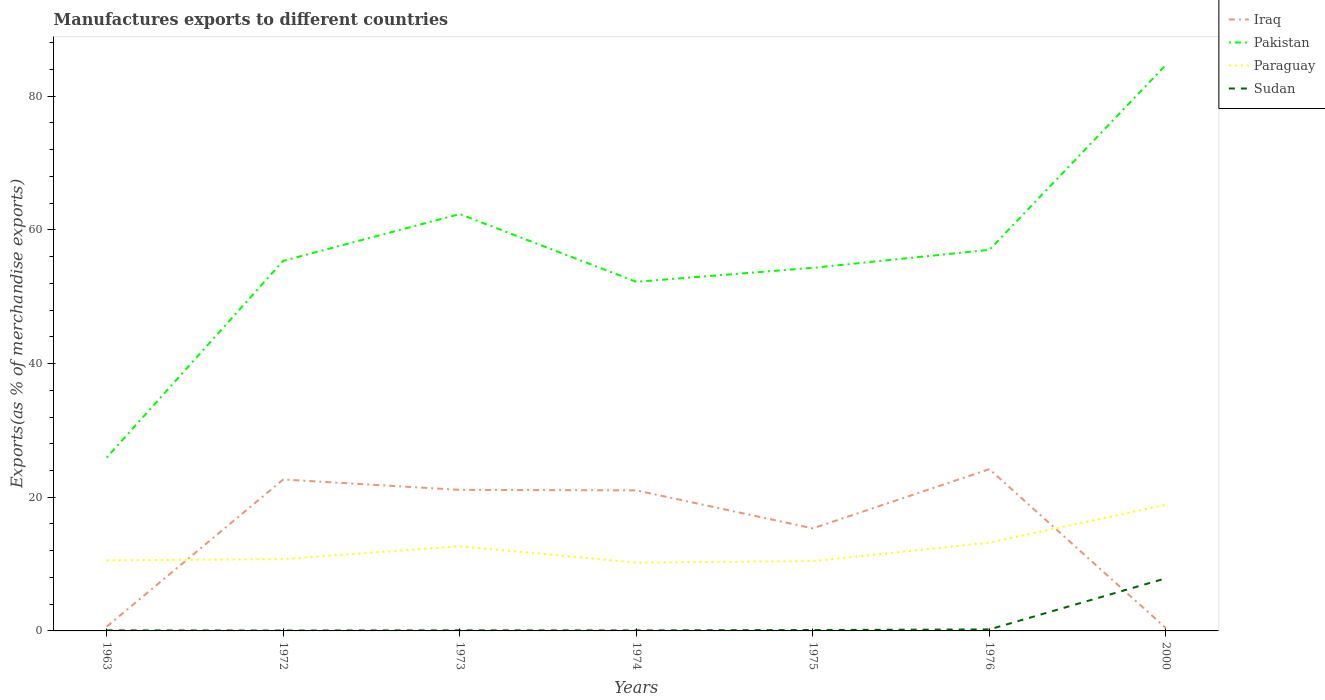How many different coloured lines are there?
Your answer should be very brief. 4. Does the line corresponding to Sudan intersect with the line corresponding to Iraq?
Offer a very short reply. Yes. Across all years, what is the maximum percentage of exports to different countries in Pakistan?
Ensure brevity in your answer.  25.94. In which year was the percentage of exports to different countries in Paraguay maximum?
Your response must be concise. 1974. What is the total percentage of exports to different countries in Paraguay in the graph?
Offer a very short reply. -2.46. What is the difference between the highest and the second highest percentage of exports to different countries in Sudan?
Ensure brevity in your answer.  7.82. What is the difference between the highest and the lowest percentage of exports to different countries in Iraq?
Make the answer very short. 5. Is the percentage of exports to different countries in Sudan strictly greater than the percentage of exports to different countries in Paraguay over the years?
Your answer should be compact. Yes. How many lines are there?
Your answer should be compact. 4. How many years are there in the graph?
Keep it short and to the point. 7. Does the graph contain any zero values?
Ensure brevity in your answer.  No. Where does the legend appear in the graph?
Make the answer very short. Top right. What is the title of the graph?
Keep it short and to the point. Manufactures exports to different countries. What is the label or title of the X-axis?
Give a very brief answer. Years. What is the label or title of the Y-axis?
Provide a succinct answer. Exports(as % of merchandise exports). What is the Exports(as % of merchandise exports) of Iraq in 1963?
Make the answer very short. 0.64. What is the Exports(as % of merchandise exports) of Pakistan in 1963?
Ensure brevity in your answer.  25.94. What is the Exports(as % of merchandise exports) in Paraguay in 1963?
Offer a terse response. 10.55. What is the Exports(as % of merchandise exports) in Sudan in 1963?
Provide a short and direct response. 0.09. What is the Exports(as % of merchandise exports) in Iraq in 1972?
Ensure brevity in your answer.  22.66. What is the Exports(as % of merchandise exports) in Pakistan in 1972?
Give a very brief answer. 55.37. What is the Exports(as % of merchandise exports) in Paraguay in 1972?
Make the answer very short. 10.75. What is the Exports(as % of merchandise exports) of Sudan in 1972?
Give a very brief answer. 0.06. What is the Exports(as % of merchandise exports) of Iraq in 1973?
Offer a terse response. 21.11. What is the Exports(as % of merchandise exports) in Pakistan in 1973?
Your answer should be compact. 62.37. What is the Exports(as % of merchandise exports) in Paraguay in 1973?
Offer a very short reply. 12.66. What is the Exports(as % of merchandise exports) in Sudan in 1973?
Make the answer very short. 0.09. What is the Exports(as % of merchandise exports) in Iraq in 1974?
Give a very brief answer. 21.03. What is the Exports(as % of merchandise exports) of Pakistan in 1974?
Offer a very short reply. 52.24. What is the Exports(as % of merchandise exports) of Paraguay in 1974?
Your answer should be very brief. 10.22. What is the Exports(as % of merchandise exports) of Sudan in 1974?
Keep it short and to the point. 0.08. What is the Exports(as % of merchandise exports) in Iraq in 1975?
Make the answer very short. 15.34. What is the Exports(as % of merchandise exports) of Pakistan in 1975?
Offer a very short reply. 54.33. What is the Exports(as % of merchandise exports) in Paraguay in 1975?
Provide a short and direct response. 10.45. What is the Exports(as % of merchandise exports) in Sudan in 1975?
Provide a short and direct response. 0.13. What is the Exports(as % of merchandise exports) of Iraq in 1976?
Keep it short and to the point. 24.21. What is the Exports(as % of merchandise exports) in Pakistan in 1976?
Your response must be concise. 57.02. What is the Exports(as % of merchandise exports) in Paraguay in 1976?
Your response must be concise. 13.21. What is the Exports(as % of merchandise exports) of Sudan in 1976?
Ensure brevity in your answer.  0.23. What is the Exports(as % of merchandise exports) in Iraq in 2000?
Offer a terse response. 0.42. What is the Exports(as % of merchandise exports) in Pakistan in 2000?
Offer a terse response. 84.7. What is the Exports(as % of merchandise exports) in Paraguay in 2000?
Give a very brief answer. 18.88. What is the Exports(as % of merchandise exports) in Sudan in 2000?
Make the answer very short. 7.87. Across all years, what is the maximum Exports(as % of merchandise exports) in Iraq?
Provide a short and direct response. 24.21. Across all years, what is the maximum Exports(as % of merchandise exports) in Pakistan?
Offer a very short reply. 84.7. Across all years, what is the maximum Exports(as % of merchandise exports) of Paraguay?
Your answer should be very brief. 18.88. Across all years, what is the maximum Exports(as % of merchandise exports) in Sudan?
Give a very brief answer. 7.87. Across all years, what is the minimum Exports(as % of merchandise exports) in Iraq?
Your response must be concise. 0.42. Across all years, what is the minimum Exports(as % of merchandise exports) in Pakistan?
Your response must be concise. 25.94. Across all years, what is the minimum Exports(as % of merchandise exports) in Paraguay?
Make the answer very short. 10.22. Across all years, what is the minimum Exports(as % of merchandise exports) in Sudan?
Provide a short and direct response. 0.06. What is the total Exports(as % of merchandise exports) in Iraq in the graph?
Make the answer very short. 105.4. What is the total Exports(as % of merchandise exports) in Pakistan in the graph?
Give a very brief answer. 391.96. What is the total Exports(as % of merchandise exports) of Paraguay in the graph?
Ensure brevity in your answer.  86.72. What is the total Exports(as % of merchandise exports) in Sudan in the graph?
Ensure brevity in your answer.  8.55. What is the difference between the Exports(as % of merchandise exports) of Iraq in 1963 and that in 1972?
Keep it short and to the point. -22.01. What is the difference between the Exports(as % of merchandise exports) in Pakistan in 1963 and that in 1972?
Offer a terse response. -29.44. What is the difference between the Exports(as % of merchandise exports) in Paraguay in 1963 and that in 1972?
Keep it short and to the point. -0.2. What is the difference between the Exports(as % of merchandise exports) of Sudan in 1963 and that in 1972?
Make the answer very short. 0.03. What is the difference between the Exports(as % of merchandise exports) in Iraq in 1963 and that in 1973?
Your answer should be compact. -20.46. What is the difference between the Exports(as % of merchandise exports) of Pakistan in 1963 and that in 1973?
Give a very brief answer. -36.44. What is the difference between the Exports(as % of merchandise exports) in Paraguay in 1963 and that in 1973?
Provide a succinct answer. -2.11. What is the difference between the Exports(as % of merchandise exports) of Sudan in 1963 and that in 1973?
Provide a short and direct response. -0. What is the difference between the Exports(as % of merchandise exports) of Iraq in 1963 and that in 1974?
Offer a terse response. -20.39. What is the difference between the Exports(as % of merchandise exports) in Pakistan in 1963 and that in 1974?
Provide a succinct answer. -26.3. What is the difference between the Exports(as % of merchandise exports) in Paraguay in 1963 and that in 1974?
Make the answer very short. 0.33. What is the difference between the Exports(as % of merchandise exports) of Sudan in 1963 and that in 1974?
Keep it short and to the point. 0.01. What is the difference between the Exports(as % of merchandise exports) of Iraq in 1963 and that in 1975?
Give a very brief answer. -14.7. What is the difference between the Exports(as % of merchandise exports) in Pakistan in 1963 and that in 1975?
Your answer should be compact. -28.39. What is the difference between the Exports(as % of merchandise exports) in Paraguay in 1963 and that in 1975?
Your response must be concise. 0.11. What is the difference between the Exports(as % of merchandise exports) of Sudan in 1963 and that in 1975?
Provide a succinct answer. -0.05. What is the difference between the Exports(as % of merchandise exports) of Iraq in 1963 and that in 1976?
Offer a terse response. -23.57. What is the difference between the Exports(as % of merchandise exports) of Pakistan in 1963 and that in 1976?
Your answer should be compact. -31.08. What is the difference between the Exports(as % of merchandise exports) in Paraguay in 1963 and that in 1976?
Offer a terse response. -2.65. What is the difference between the Exports(as % of merchandise exports) of Sudan in 1963 and that in 1976?
Offer a very short reply. -0.14. What is the difference between the Exports(as % of merchandise exports) of Iraq in 1963 and that in 2000?
Offer a very short reply. 0.23. What is the difference between the Exports(as % of merchandise exports) of Pakistan in 1963 and that in 2000?
Keep it short and to the point. -58.76. What is the difference between the Exports(as % of merchandise exports) in Paraguay in 1963 and that in 2000?
Give a very brief answer. -8.32. What is the difference between the Exports(as % of merchandise exports) of Sudan in 1963 and that in 2000?
Give a very brief answer. -7.79. What is the difference between the Exports(as % of merchandise exports) of Iraq in 1972 and that in 1973?
Your answer should be very brief. 1.55. What is the difference between the Exports(as % of merchandise exports) in Pakistan in 1972 and that in 1973?
Your answer should be very brief. -7. What is the difference between the Exports(as % of merchandise exports) of Paraguay in 1972 and that in 1973?
Your response must be concise. -1.91. What is the difference between the Exports(as % of merchandise exports) of Sudan in 1972 and that in 1973?
Ensure brevity in your answer.  -0.03. What is the difference between the Exports(as % of merchandise exports) of Iraq in 1972 and that in 1974?
Offer a very short reply. 1.62. What is the difference between the Exports(as % of merchandise exports) in Pakistan in 1972 and that in 1974?
Ensure brevity in your answer.  3.14. What is the difference between the Exports(as % of merchandise exports) in Paraguay in 1972 and that in 1974?
Your response must be concise. 0.53. What is the difference between the Exports(as % of merchandise exports) of Sudan in 1972 and that in 1974?
Provide a short and direct response. -0.02. What is the difference between the Exports(as % of merchandise exports) of Iraq in 1972 and that in 1975?
Offer a very short reply. 7.31. What is the difference between the Exports(as % of merchandise exports) of Pakistan in 1972 and that in 1975?
Offer a very short reply. 1.05. What is the difference between the Exports(as % of merchandise exports) of Paraguay in 1972 and that in 1975?
Provide a short and direct response. 0.31. What is the difference between the Exports(as % of merchandise exports) of Sudan in 1972 and that in 1975?
Make the answer very short. -0.08. What is the difference between the Exports(as % of merchandise exports) in Iraq in 1972 and that in 1976?
Your answer should be compact. -1.55. What is the difference between the Exports(as % of merchandise exports) of Pakistan in 1972 and that in 1976?
Your answer should be compact. -1.64. What is the difference between the Exports(as % of merchandise exports) of Paraguay in 1972 and that in 1976?
Your response must be concise. -2.46. What is the difference between the Exports(as % of merchandise exports) of Sudan in 1972 and that in 1976?
Keep it short and to the point. -0.17. What is the difference between the Exports(as % of merchandise exports) of Iraq in 1972 and that in 2000?
Provide a short and direct response. 22.24. What is the difference between the Exports(as % of merchandise exports) in Pakistan in 1972 and that in 2000?
Provide a succinct answer. -29.32. What is the difference between the Exports(as % of merchandise exports) in Paraguay in 1972 and that in 2000?
Provide a succinct answer. -8.12. What is the difference between the Exports(as % of merchandise exports) of Sudan in 1972 and that in 2000?
Give a very brief answer. -7.82. What is the difference between the Exports(as % of merchandise exports) of Iraq in 1973 and that in 1974?
Give a very brief answer. 0.07. What is the difference between the Exports(as % of merchandise exports) of Pakistan in 1973 and that in 1974?
Offer a terse response. 10.14. What is the difference between the Exports(as % of merchandise exports) of Paraguay in 1973 and that in 1974?
Your answer should be very brief. 2.44. What is the difference between the Exports(as % of merchandise exports) of Sudan in 1973 and that in 1974?
Provide a succinct answer. 0.01. What is the difference between the Exports(as % of merchandise exports) in Iraq in 1973 and that in 1975?
Your answer should be very brief. 5.76. What is the difference between the Exports(as % of merchandise exports) of Pakistan in 1973 and that in 1975?
Make the answer very short. 8.05. What is the difference between the Exports(as % of merchandise exports) of Paraguay in 1973 and that in 1975?
Keep it short and to the point. 2.22. What is the difference between the Exports(as % of merchandise exports) of Sudan in 1973 and that in 1975?
Provide a succinct answer. -0.05. What is the difference between the Exports(as % of merchandise exports) of Iraq in 1973 and that in 1976?
Provide a short and direct response. -3.1. What is the difference between the Exports(as % of merchandise exports) in Pakistan in 1973 and that in 1976?
Keep it short and to the point. 5.36. What is the difference between the Exports(as % of merchandise exports) in Paraguay in 1973 and that in 1976?
Give a very brief answer. -0.55. What is the difference between the Exports(as % of merchandise exports) in Sudan in 1973 and that in 1976?
Give a very brief answer. -0.14. What is the difference between the Exports(as % of merchandise exports) of Iraq in 1973 and that in 2000?
Offer a very short reply. 20.69. What is the difference between the Exports(as % of merchandise exports) of Pakistan in 1973 and that in 2000?
Offer a very short reply. -22.32. What is the difference between the Exports(as % of merchandise exports) in Paraguay in 1973 and that in 2000?
Provide a succinct answer. -6.21. What is the difference between the Exports(as % of merchandise exports) in Sudan in 1973 and that in 2000?
Make the answer very short. -7.79. What is the difference between the Exports(as % of merchandise exports) of Iraq in 1974 and that in 1975?
Your response must be concise. 5.69. What is the difference between the Exports(as % of merchandise exports) in Pakistan in 1974 and that in 1975?
Your response must be concise. -2.09. What is the difference between the Exports(as % of merchandise exports) in Paraguay in 1974 and that in 1975?
Your answer should be compact. -0.22. What is the difference between the Exports(as % of merchandise exports) of Sudan in 1974 and that in 1975?
Offer a terse response. -0.06. What is the difference between the Exports(as % of merchandise exports) of Iraq in 1974 and that in 1976?
Provide a short and direct response. -3.18. What is the difference between the Exports(as % of merchandise exports) of Pakistan in 1974 and that in 1976?
Ensure brevity in your answer.  -4.78. What is the difference between the Exports(as % of merchandise exports) in Paraguay in 1974 and that in 1976?
Offer a terse response. -2.99. What is the difference between the Exports(as % of merchandise exports) of Sudan in 1974 and that in 1976?
Your response must be concise. -0.15. What is the difference between the Exports(as % of merchandise exports) of Iraq in 1974 and that in 2000?
Ensure brevity in your answer.  20.61. What is the difference between the Exports(as % of merchandise exports) in Pakistan in 1974 and that in 2000?
Provide a succinct answer. -32.46. What is the difference between the Exports(as % of merchandise exports) in Paraguay in 1974 and that in 2000?
Offer a terse response. -8.66. What is the difference between the Exports(as % of merchandise exports) of Sudan in 1974 and that in 2000?
Give a very brief answer. -7.8. What is the difference between the Exports(as % of merchandise exports) of Iraq in 1975 and that in 1976?
Provide a short and direct response. -8.87. What is the difference between the Exports(as % of merchandise exports) in Pakistan in 1975 and that in 1976?
Ensure brevity in your answer.  -2.69. What is the difference between the Exports(as % of merchandise exports) in Paraguay in 1975 and that in 1976?
Ensure brevity in your answer.  -2.76. What is the difference between the Exports(as % of merchandise exports) of Sudan in 1975 and that in 1976?
Your response must be concise. -0.09. What is the difference between the Exports(as % of merchandise exports) of Iraq in 1975 and that in 2000?
Keep it short and to the point. 14.93. What is the difference between the Exports(as % of merchandise exports) of Pakistan in 1975 and that in 2000?
Provide a short and direct response. -30.37. What is the difference between the Exports(as % of merchandise exports) in Paraguay in 1975 and that in 2000?
Offer a very short reply. -8.43. What is the difference between the Exports(as % of merchandise exports) of Sudan in 1975 and that in 2000?
Your answer should be compact. -7.74. What is the difference between the Exports(as % of merchandise exports) in Iraq in 1976 and that in 2000?
Offer a terse response. 23.79. What is the difference between the Exports(as % of merchandise exports) in Pakistan in 1976 and that in 2000?
Give a very brief answer. -27.68. What is the difference between the Exports(as % of merchandise exports) in Paraguay in 1976 and that in 2000?
Make the answer very short. -5.67. What is the difference between the Exports(as % of merchandise exports) in Sudan in 1976 and that in 2000?
Ensure brevity in your answer.  -7.65. What is the difference between the Exports(as % of merchandise exports) of Iraq in 1963 and the Exports(as % of merchandise exports) of Pakistan in 1972?
Provide a short and direct response. -54.73. What is the difference between the Exports(as % of merchandise exports) of Iraq in 1963 and the Exports(as % of merchandise exports) of Paraguay in 1972?
Your response must be concise. -10.11. What is the difference between the Exports(as % of merchandise exports) in Iraq in 1963 and the Exports(as % of merchandise exports) in Sudan in 1972?
Offer a very short reply. 0.58. What is the difference between the Exports(as % of merchandise exports) of Pakistan in 1963 and the Exports(as % of merchandise exports) of Paraguay in 1972?
Your answer should be compact. 15.18. What is the difference between the Exports(as % of merchandise exports) in Pakistan in 1963 and the Exports(as % of merchandise exports) in Sudan in 1972?
Ensure brevity in your answer.  25.88. What is the difference between the Exports(as % of merchandise exports) in Paraguay in 1963 and the Exports(as % of merchandise exports) in Sudan in 1972?
Your response must be concise. 10.5. What is the difference between the Exports(as % of merchandise exports) of Iraq in 1963 and the Exports(as % of merchandise exports) of Pakistan in 1973?
Your response must be concise. -61.73. What is the difference between the Exports(as % of merchandise exports) in Iraq in 1963 and the Exports(as % of merchandise exports) in Paraguay in 1973?
Give a very brief answer. -12.02. What is the difference between the Exports(as % of merchandise exports) of Iraq in 1963 and the Exports(as % of merchandise exports) of Sudan in 1973?
Give a very brief answer. 0.55. What is the difference between the Exports(as % of merchandise exports) of Pakistan in 1963 and the Exports(as % of merchandise exports) of Paraguay in 1973?
Offer a terse response. 13.27. What is the difference between the Exports(as % of merchandise exports) in Pakistan in 1963 and the Exports(as % of merchandise exports) in Sudan in 1973?
Your response must be concise. 25.85. What is the difference between the Exports(as % of merchandise exports) in Paraguay in 1963 and the Exports(as % of merchandise exports) in Sudan in 1973?
Keep it short and to the point. 10.47. What is the difference between the Exports(as % of merchandise exports) of Iraq in 1963 and the Exports(as % of merchandise exports) of Pakistan in 1974?
Offer a very short reply. -51.6. What is the difference between the Exports(as % of merchandise exports) of Iraq in 1963 and the Exports(as % of merchandise exports) of Paraguay in 1974?
Your response must be concise. -9.58. What is the difference between the Exports(as % of merchandise exports) of Iraq in 1963 and the Exports(as % of merchandise exports) of Sudan in 1974?
Give a very brief answer. 0.56. What is the difference between the Exports(as % of merchandise exports) of Pakistan in 1963 and the Exports(as % of merchandise exports) of Paraguay in 1974?
Your answer should be compact. 15.71. What is the difference between the Exports(as % of merchandise exports) in Pakistan in 1963 and the Exports(as % of merchandise exports) in Sudan in 1974?
Give a very brief answer. 25.86. What is the difference between the Exports(as % of merchandise exports) of Paraguay in 1963 and the Exports(as % of merchandise exports) of Sudan in 1974?
Ensure brevity in your answer.  10.48. What is the difference between the Exports(as % of merchandise exports) in Iraq in 1963 and the Exports(as % of merchandise exports) in Pakistan in 1975?
Offer a terse response. -53.68. What is the difference between the Exports(as % of merchandise exports) in Iraq in 1963 and the Exports(as % of merchandise exports) in Paraguay in 1975?
Your answer should be very brief. -9.8. What is the difference between the Exports(as % of merchandise exports) in Iraq in 1963 and the Exports(as % of merchandise exports) in Sudan in 1975?
Offer a very short reply. 0.51. What is the difference between the Exports(as % of merchandise exports) in Pakistan in 1963 and the Exports(as % of merchandise exports) in Paraguay in 1975?
Make the answer very short. 15.49. What is the difference between the Exports(as % of merchandise exports) of Pakistan in 1963 and the Exports(as % of merchandise exports) of Sudan in 1975?
Make the answer very short. 25.8. What is the difference between the Exports(as % of merchandise exports) in Paraguay in 1963 and the Exports(as % of merchandise exports) in Sudan in 1975?
Provide a short and direct response. 10.42. What is the difference between the Exports(as % of merchandise exports) of Iraq in 1963 and the Exports(as % of merchandise exports) of Pakistan in 1976?
Give a very brief answer. -56.38. What is the difference between the Exports(as % of merchandise exports) in Iraq in 1963 and the Exports(as % of merchandise exports) in Paraguay in 1976?
Offer a terse response. -12.57. What is the difference between the Exports(as % of merchandise exports) of Iraq in 1963 and the Exports(as % of merchandise exports) of Sudan in 1976?
Give a very brief answer. 0.42. What is the difference between the Exports(as % of merchandise exports) of Pakistan in 1963 and the Exports(as % of merchandise exports) of Paraguay in 1976?
Your answer should be compact. 12.73. What is the difference between the Exports(as % of merchandise exports) of Pakistan in 1963 and the Exports(as % of merchandise exports) of Sudan in 1976?
Your answer should be compact. 25.71. What is the difference between the Exports(as % of merchandise exports) of Paraguay in 1963 and the Exports(as % of merchandise exports) of Sudan in 1976?
Keep it short and to the point. 10.33. What is the difference between the Exports(as % of merchandise exports) of Iraq in 1963 and the Exports(as % of merchandise exports) of Pakistan in 2000?
Give a very brief answer. -84.05. What is the difference between the Exports(as % of merchandise exports) of Iraq in 1963 and the Exports(as % of merchandise exports) of Paraguay in 2000?
Your answer should be very brief. -18.23. What is the difference between the Exports(as % of merchandise exports) in Iraq in 1963 and the Exports(as % of merchandise exports) in Sudan in 2000?
Ensure brevity in your answer.  -7.23. What is the difference between the Exports(as % of merchandise exports) in Pakistan in 1963 and the Exports(as % of merchandise exports) in Paraguay in 2000?
Your response must be concise. 7.06. What is the difference between the Exports(as % of merchandise exports) in Pakistan in 1963 and the Exports(as % of merchandise exports) in Sudan in 2000?
Give a very brief answer. 18.06. What is the difference between the Exports(as % of merchandise exports) in Paraguay in 1963 and the Exports(as % of merchandise exports) in Sudan in 2000?
Your response must be concise. 2.68. What is the difference between the Exports(as % of merchandise exports) in Iraq in 1972 and the Exports(as % of merchandise exports) in Pakistan in 1973?
Offer a very short reply. -39.72. What is the difference between the Exports(as % of merchandise exports) in Iraq in 1972 and the Exports(as % of merchandise exports) in Paraguay in 1973?
Ensure brevity in your answer.  9.99. What is the difference between the Exports(as % of merchandise exports) in Iraq in 1972 and the Exports(as % of merchandise exports) in Sudan in 1973?
Provide a succinct answer. 22.57. What is the difference between the Exports(as % of merchandise exports) in Pakistan in 1972 and the Exports(as % of merchandise exports) in Paraguay in 1973?
Provide a short and direct response. 42.71. What is the difference between the Exports(as % of merchandise exports) of Pakistan in 1972 and the Exports(as % of merchandise exports) of Sudan in 1973?
Provide a short and direct response. 55.29. What is the difference between the Exports(as % of merchandise exports) of Paraguay in 1972 and the Exports(as % of merchandise exports) of Sudan in 1973?
Give a very brief answer. 10.66. What is the difference between the Exports(as % of merchandise exports) in Iraq in 1972 and the Exports(as % of merchandise exports) in Pakistan in 1974?
Keep it short and to the point. -29.58. What is the difference between the Exports(as % of merchandise exports) of Iraq in 1972 and the Exports(as % of merchandise exports) of Paraguay in 1974?
Provide a short and direct response. 12.43. What is the difference between the Exports(as % of merchandise exports) of Iraq in 1972 and the Exports(as % of merchandise exports) of Sudan in 1974?
Give a very brief answer. 22.58. What is the difference between the Exports(as % of merchandise exports) in Pakistan in 1972 and the Exports(as % of merchandise exports) in Paraguay in 1974?
Offer a terse response. 45.15. What is the difference between the Exports(as % of merchandise exports) of Pakistan in 1972 and the Exports(as % of merchandise exports) of Sudan in 1974?
Provide a succinct answer. 55.3. What is the difference between the Exports(as % of merchandise exports) in Paraguay in 1972 and the Exports(as % of merchandise exports) in Sudan in 1974?
Your answer should be compact. 10.67. What is the difference between the Exports(as % of merchandise exports) of Iraq in 1972 and the Exports(as % of merchandise exports) of Pakistan in 1975?
Your answer should be very brief. -31.67. What is the difference between the Exports(as % of merchandise exports) of Iraq in 1972 and the Exports(as % of merchandise exports) of Paraguay in 1975?
Give a very brief answer. 12.21. What is the difference between the Exports(as % of merchandise exports) of Iraq in 1972 and the Exports(as % of merchandise exports) of Sudan in 1975?
Make the answer very short. 22.52. What is the difference between the Exports(as % of merchandise exports) of Pakistan in 1972 and the Exports(as % of merchandise exports) of Paraguay in 1975?
Your response must be concise. 44.93. What is the difference between the Exports(as % of merchandise exports) of Pakistan in 1972 and the Exports(as % of merchandise exports) of Sudan in 1975?
Ensure brevity in your answer.  55.24. What is the difference between the Exports(as % of merchandise exports) in Paraguay in 1972 and the Exports(as % of merchandise exports) in Sudan in 1975?
Provide a short and direct response. 10.62. What is the difference between the Exports(as % of merchandise exports) of Iraq in 1972 and the Exports(as % of merchandise exports) of Pakistan in 1976?
Provide a succinct answer. -34.36. What is the difference between the Exports(as % of merchandise exports) of Iraq in 1972 and the Exports(as % of merchandise exports) of Paraguay in 1976?
Offer a very short reply. 9.45. What is the difference between the Exports(as % of merchandise exports) in Iraq in 1972 and the Exports(as % of merchandise exports) in Sudan in 1976?
Make the answer very short. 22.43. What is the difference between the Exports(as % of merchandise exports) in Pakistan in 1972 and the Exports(as % of merchandise exports) in Paraguay in 1976?
Ensure brevity in your answer.  42.17. What is the difference between the Exports(as % of merchandise exports) of Pakistan in 1972 and the Exports(as % of merchandise exports) of Sudan in 1976?
Ensure brevity in your answer.  55.15. What is the difference between the Exports(as % of merchandise exports) in Paraguay in 1972 and the Exports(as % of merchandise exports) in Sudan in 1976?
Offer a very short reply. 10.53. What is the difference between the Exports(as % of merchandise exports) in Iraq in 1972 and the Exports(as % of merchandise exports) in Pakistan in 2000?
Ensure brevity in your answer.  -62.04. What is the difference between the Exports(as % of merchandise exports) in Iraq in 1972 and the Exports(as % of merchandise exports) in Paraguay in 2000?
Ensure brevity in your answer.  3.78. What is the difference between the Exports(as % of merchandise exports) of Iraq in 1972 and the Exports(as % of merchandise exports) of Sudan in 2000?
Provide a short and direct response. 14.78. What is the difference between the Exports(as % of merchandise exports) in Pakistan in 1972 and the Exports(as % of merchandise exports) in Paraguay in 2000?
Keep it short and to the point. 36.5. What is the difference between the Exports(as % of merchandise exports) of Pakistan in 1972 and the Exports(as % of merchandise exports) of Sudan in 2000?
Provide a short and direct response. 47.5. What is the difference between the Exports(as % of merchandise exports) in Paraguay in 1972 and the Exports(as % of merchandise exports) in Sudan in 2000?
Provide a short and direct response. 2.88. What is the difference between the Exports(as % of merchandise exports) of Iraq in 1973 and the Exports(as % of merchandise exports) of Pakistan in 1974?
Keep it short and to the point. -31.13. What is the difference between the Exports(as % of merchandise exports) of Iraq in 1973 and the Exports(as % of merchandise exports) of Paraguay in 1974?
Offer a very short reply. 10.88. What is the difference between the Exports(as % of merchandise exports) of Iraq in 1973 and the Exports(as % of merchandise exports) of Sudan in 1974?
Give a very brief answer. 21.03. What is the difference between the Exports(as % of merchandise exports) of Pakistan in 1973 and the Exports(as % of merchandise exports) of Paraguay in 1974?
Ensure brevity in your answer.  52.15. What is the difference between the Exports(as % of merchandise exports) of Pakistan in 1973 and the Exports(as % of merchandise exports) of Sudan in 1974?
Your answer should be compact. 62.29. What is the difference between the Exports(as % of merchandise exports) in Paraguay in 1973 and the Exports(as % of merchandise exports) in Sudan in 1974?
Make the answer very short. 12.58. What is the difference between the Exports(as % of merchandise exports) of Iraq in 1973 and the Exports(as % of merchandise exports) of Pakistan in 1975?
Provide a short and direct response. -33.22. What is the difference between the Exports(as % of merchandise exports) of Iraq in 1973 and the Exports(as % of merchandise exports) of Paraguay in 1975?
Your answer should be very brief. 10.66. What is the difference between the Exports(as % of merchandise exports) in Iraq in 1973 and the Exports(as % of merchandise exports) in Sudan in 1975?
Your response must be concise. 20.97. What is the difference between the Exports(as % of merchandise exports) of Pakistan in 1973 and the Exports(as % of merchandise exports) of Paraguay in 1975?
Make the answer very short. 51.93. What is the difference between the Exports(as % of merchandise exports) in Pakistan in 1973 and the Exports(as % of merchandise exports) in Sudan in 1975?
Provide a succinct answer. 62.24. What is the difference between the Exports(as % of merchandise exports) of Paraguay in 1973 and the Exports(as % of merchandise exports) of Sudan in 1975?
Your answer should be very brief. 12.53. What is the difference between the Exports(as % of merchandise exports) of Iraq in 1973 and the Exports(as % of merchandise exports) of Pakistan in 1976?
Offer a terse response. -35.91. What is the difference between the Exports(as % of merchandise exports) in Iraq in 1973 and the Exports(as % of merchandise exports) in Paraguay in 1976?
Ensure brevity in your answer.  7.9. What is the difference between the Exports(as % of merchandise exports) in Iraq in 1973 and the Exports(as % of merchandise exports) in Sudan in 1976?
Your answer should be compact. 20.88. What is the difference between the Exports(as % of merchandise exports) in Pakistan in 1973 and the Exports(as % of merchandise exports) in Paraguay in 1976?
Provide a short and direct response. 49.17. What is the difference between the Exports(as % of merchandise exports) in Pakistan in 1973 and the Exports(as % of merchandise exports) in Sudan in 1976?
Ensure brevity in your answer.  62.15. What is the difference between the Exports(as % of merchandise exports) of Paraguay in 1973 and the Exports(as % of merchandise exports) of Sudan in 1976?
Offer a very short reply. 12.44. What is the difference between the Exports(as % of merchandise exports) of Iraq in 1973 and the Exports(as % of merchandise exports) of Pakistan in 2000?
Your answer should be very brief. -63.59. What is the difference between the Exports(as % of merchandise exports) in Iraq in 1973 and the Exports(as % of merchandise exports) in Paraguay in 2000?
Your answer should be compact. 2.23. What is the difference between the Exports(as % of merchandise exports) in Iraq in 1973 and the Exports(as % of merchandise exports) in Sudan in 2000?
Your answer should be very brief. 13.23. What is the difference between the Exports(as % of merchandise exports) in Pakistan in 1973 and the Exports(as % of merchandise exports) in Paraguay in 2000?
Give a very brief answer. 43.5. What is the difference between the Exports(as % of merchandise exports) in Pakistan in 1973 and the Exports(as % of merchandise exports) in Sudan in 2000?
Keep it short and to the point. 54.5. What is the difference between the Exports(as % of merchandise exports) in Paraguay in 1973 and the Exports(as % of merchandise exports) in Sudan in 2000?
Provide a succinct answer. 4.79. What is the difference between the Exports(as % of merchandise exports) in Iraq in 1974 and the Exports(as % of merchandise exports) in Pakistan in 1975?
Your answer should be very brief. -33.3. What is the difference between the Exports(as % of merchandise exports) in Iraq in 1974 and the Exports(as % of merchandise exports) in Paraguay in 1975?
Offer a terse response. 10.59. What is the difference between the Exports(as % of merchandise exports) of Iraq in 1974 and the Exports(as % of merchandise exports) of Sudan in 1975?
Your answer should be compact. 20.9. What is the difference between the Exports(as % of merchandise exports) of Pakistan in 1974 and the Exports(as % of merchandise exports) of Paraguay in 1975?
Make the answer very short. 41.79. What is the difference between the Exports(as % of merchandise exports) of Pakistan in 1974 and the Exports(as % of merchandise exports) of Sudan in 1975?
Give a very brief answer. 52.1. What is the difference between the Exports(as % of merchandise exports) in Paraguay in 1974 and the Exports(as % of merchandise exports) in Sudan in 1975?
Provide a succinct answer. 10.09. What is the difference between the Exports(as % of merchandise exports) in Iraq in 1974 and the Exports(as % of merchandise exports) in Pakistan in 1976?
Make the answer very short. -35.99. What is the difference between the Exports(as % of merchandise exports) in Iraq in 1974 and the Exports(as % of merchandise exports) in Paraguay in 1976?
Ensure brevity in your answer.  7.82. What is the difference between the Exports(as % of merchandise exports) in Iraq in 1974 and the Exports(as % of merchandise exports) in Sudan in 1976?
Your response must be concise. 20.81. What is the difference between the Exports(as % of merchandise exports) of Pakistan in 1974 and the Exports(as % of merchandise exports) of Paraguay in 1976?
Ensure brevity in your answer.  39.03. What is the difference between the Exports(as % of merchandise exports) in Pakistan in 1974 and the Exports(as % of merchandise exports) in Sudan in 1976?
Provide a succinct answer. 52.01. What is the difference between the Exports(as % of merchandise exports) of Paraguay in 1974 and the Exports(as % of merchandise exports) of Sudan in 1976?
Your answer should be compact. 10. What is the difference between the Exports(as % of merchandise exports) in Iraq in 1974 and the Exports(as % of merchandise exports) in Pakistan in 2000?
Offer a terse response. -63.67. What is the difference between the Exports(as % of merchandise exports) in Iraq in 1974 and the Exports(as % of merchandise exports) in Paraguay in 2000?
Keep it short and to the point. 2.15. What is the difference between the Exports(as % of merchandise exports) in Iraq in 1974 and the Exports(as % of merchandise exports) in Sudan in 2000?
Give a very brief answer. 13.16. What is the difference between the Exports(as % of merchandise exports) of Pakistan in 1974 and the Exports(as % of merchandise exports) of Paraguay in 2000?
Give a very brief answer. 33.36. What is the difference between the Exports(as % of merchandise exports) of Pakistan in 1974 and the Exports(as % of merchandise exports) of Sudan in 2000?
Ensure brevity in your answer.  44.36. What is the difference between the Exports(as % of merchandise exports) of Paraguay in 1974 and the Exports(as % of merchandise exports) of Sudan in 2000?
Give a very brief answer. 2.35. What is the difference between the Exports(as % of merchandise exports) in Iraq in 1975 and the Exports(as % of merchandise exports) in Pakistan in 1976?
Offer a terse response. -41.68. What is the difference between the Exports(as % of merchandise exports) of Iraq in 1975 and the Exports(as % of merchandise exports) of Paraguay in 1976?
Give a very brief answer. 2.13. What is the difference between the Exports(as % of merchandise exports) of Iraq in 1975 and the Exports(as % of merchandise exports) of Sudan in 1976?
Provide a short and direct response. 15.12. What is the difference between the Exports(as % of merchandise exports) in Pakistan in 1975 and the Exports(as % of merchandise exports) in Paraguay in 1976?
Keep it short and to the point. 41.12. What is the difference between the Exports(as % of merchandise exports) in Pakistan in 1975 and the Exports(as % of merchandise exports) in Sudan in 1976?
Offer a very short reply. 54.1. What is the difference between the Exports(as % of merchandise exports) in Paraguay in 1975 and the Exports(as % of merchandise exports) in Sudan in 1976?
Keep it short and to the point. 10.22. What is the difference between the Exports(as % of merchandise exports) in Iraq in 1975 and the Exports(as % of merchandise exports) in Pakistan in 2000?
Provide a short and direct response. -69.35. What is the difference between the Exports(as % of merchandise exports) of Iraq in 1975 and the Exports(as % of merchandise exports) of Paraguay in 2000?
Offer a terse response. -3.53. What is the difference between the Exports(as % of merchandise exports) of Iraq in 1975 and the Exports(as % of merchandise exports) of Sudan in 2000?
Provide a short and direct response. 7.47. What is the difference between the Exports(as % of merchandise exports) of Pakistan in 1975 and the Exports(as % of merchandise exports) of Paraguay in 2000?
Your answer should be compact. 35.45. What is the difference between the Exports(as % of merchandise exports) in Pakistan in 1975 and the Exports(as % of merchandise exports) in Sudan in 2000?
Give a very brief answer. 46.45. What is the difference between the Exports(as % of merchandise exports) of Paraguay in 1975 and the Exports(as % of merchandise exports) of Sudan in 2000?
Your answer should be compact. 2.57. What is the difference between the Exports(as % of merchandise exports) of Iraq in 1976 and the Exports(as % of merchandise exports) of Pakistan in 2000?
Ensure brevity in your answer.  -60.49. What is the difference between the Exports(as % of merchandise exports) in Iraq in 1976 and the Exports(as % of merchandise exports) in Paraguay in 2000?
Your answer should be compact. 5.33. What is the difference between the Exports(as % of merchandise exports) in Iraq in 1976 and the Exports(as % of merchandise exports) in Sudan in 2000?
Give a very brief answer. 16.33. What is the difference between the Exports(as % of merchandise exports) of Pakistan in 1976 and the Exports(as % of merchandise exports) of Paraguay in 2000?
Your response must be concise. 38.14. What is the difference between the Exports(as % of merchandise exports) in Pakistan in 1976 and the Exports(as % of merchandise exports) in Sudan in 2000?
Your response must be concise. 49.14. What is the difference between the Exports(as % of merchandise exports) in Paraguay in 1976 and the Exports(as % of merchandise exports) in Sudan in 2000?
Your answer should be very brief. 5.33. What is the average Exports(as % of merchandise exports) of Iraq per year?
Make the answer very short. 15.06. What is the average Exports(as % of merchandise exports) of Pakistan per year?
Make the answer very short. 55.99. What is the average Exports(as % of merchandise exports) in Paraguay per year?
Make the answer very short. 12.39. What is the average Exports(as % of merchandise exports) in Sudan per year?
Provide a short and direct response. 1.22. In the year 1963, what is the difference between the Exports(as % of merchandise exports) of Iraq and Exports(as % of merchandise exports) of Pakistan?
Keep it short and to the point. -25.29. In the year 1963, what is the difference between the Exports(as % of merchandise exports) of Iraq and Exports(as % of merchandise exports) of Paraguay?
Provide a short and direct response. -9.91. In the year 1963, what is the difference between the Exports(as % of merchandise exports) of Iraq and Exports(as % of merchandise exports) of Sudan?
Offer a very short reply. 0.56. In the year 1963, what is the difference between the Exports(as % of merchandise exports) of Pakistan and Exports(as % of merchandise exports) of Paraguay?
Make the answer very short. 15.38. In the year 1963, what is the difference between the Exports(as % of merchandise exports) in Pakistan and Exports(as % of merchandise exports) in Sudan?
Your response must be concise. 25.85. In the year 1963, what is the difference between the Exports(as % of merchandise exports) in Paraguay and Exports(as % of merchandise exports) in Sudan?
Your answer should be very brief. 10.47. In the year 1972, what is the difference between the Exports(as % of merchandise exports) of Iraq and Exports(as % of merchandise exports) of Pakistan?
Your response must be concise. -32.72. In the year 1972, what is the difference between the Exports(as % of merchandise exports) in Iraq and Exports(as % of merchandise exports) in Paraguay?
Provide a succinct answer. 11.9. In the year 1972, what is the difference between the Exports(as % of merchandise exports) of Iraq and Exports(as % of merchandise exports) of Sudan?
Provide a short and direct response. 22.6. In the year 1972, what is the difference between the Exports(as % of merchandise exports) of Pakistan and Exports(as % of merchandise exports) of Paraguay?
Provide a short and direct response. 44.62. In the year 1972, what is the difference between the Exports(as % of merchandise exports) in Pakistan and Exports(as % of merchandise exports) in Sudan?
Provide a short and direct response. 55.32. In the year 1972, what is the difference between the Exports(as % of merchandise exports) in Paraguay and Exports(as % of merchandise exports) in Sudan?
Your answer should be very brief. 10.7. In the year 1973, what is the difference between the Exports(as % of merchandise exports) in Iraq and Exports(as % of merchandise exports) in Pakistan?
Your response must be concise. -41.27. In the year 1973, what is the difference between the Exports(as % of merchandise exports) of Iraq and Exports(as % of merchandise exports) of Paraguay?
Your response must be concise. 8.44. In the year 1973, what is the difference between the Exports(as % of merchandise exports) of Iraq and Exports(as % of merchandise exports) of Sudan?
Keep it short and to the point. 21.02. In the year 1973, what is the difference between the Exports(as % of merchandise exports) of Pakistan and Exports(as % of merchandise exports) of Paraguay?
Your response must be concise. 49.71. In the year 1973, what is the difference between the Exports(as % of merchandise exports) in Pakistan and Exports(as % of merchandise exports) in Sudan?
Provide a succinct answer. 62.29. In the year 1973, what is the difference between the Exports(as % of merchandise exports) in Paraguay and Exports(as % of merchandise exports) in Sudan?
Provide a short and direct response. 12.57. In the year 1974, what is the difference between the Exports(as % of merchandise exports) of Iraq and Exports(as % of merchandise exports) of Pakistan?
Your answer should be compact. -31.21. In the year 1974, what is the difference between the Exports(as % of merchandise exports) of Iraq and Exports(as % of merchandise exports) of Paraguay?
Make the answer very short. 10.81. In the year 1974, what is the difference between the Exports(as % of merchandise exports) in Iraq and Exports(as % of merchandise exports) in Sudan?
Provide a succinct answer. 20.95. In the year 1974, what is the difference between the Exports(as % of merchandise exports) in Pakistan and Exports(as % of merchandise exports) in Paraguay?
Make the answer very short. 42.02. In the year 1974, what is the difference between the Exports(as % of merchandise exports) of Pakistan and Exports(as % of merchandise exports) of Sudan?
Keep it short and to the point. 52.16. In the year 1974, what is the difference between the Exports(as % of merchandise exports) of Paraguay and Exports(as % of merchandise exports) of Sudan?
Ensure brevity in your answer.  10.14. In the year 1975, what is the difference between the Exports(as % of merchandise exports) in Iraq and Exports(as % of merchandise exports) in Pakistan?
Provide a succinct answer. -38.98. In the year 1975, what is the difference between the Exports(as % of merchandise exports) in Iraq and Exports(as % of merchandise exports) in Paraguay?
Offer a terse response. 4.9. In the year 1975, what is the difference between the Exports(as % of merchandise exports) of Iraq and Exports(as % of merchandise exports) of Sudan?
Provide a short and direct response. 15.21. In the year 1975, what is the difference between the Exports(as % of merchandise exports) of Pakistan and Exports(as % of merchandise exports) of Paraguay?
Offer a terse response. 43.88. In the year 1975, what is the difference between the Exports(as % of merchandise exports) in Pakistan and Exports(as % of merchandise exports) in Sudan?
Give a very brief answer. 54.19. In the year 1975, what is the difference between the Exports(as % of merchandise exports) in Paraguay and Exports(as % of merchandise exports) in Sudan?
Provide a short and direct response. 10.31. In the year 1976, what is the difference between the Exports(as % of merchandise exports) of Iraq and Exports(as % of merchandise exports) of Pakistan?
Your answer should be compact. -32.81. In the year 1976, what is the difference between the Exports(as % of merchandise exports) in Iraq and Exports(as % of merchandise exports) in Paraguay?
Make the answer very short. 11. In the year 1976, what is the difference between the Exports(as % of merchandise exports) in Iraq and Exports(as % of merchandise exports) in Sudan?
Offer a very short reply. 23.98. In the year 1976, what is the difference between the Exports(as % of merchandise exports) of Pakistan and Exports(as % of merchandise exports) of Paraguay?
Provide a short and direct response. 43.81. In the year 1976, what is the difference between the Exports(as % of merchandise exports) in Pakistan and Exports(as % of merchandise exports) in Sudan?
Give a very brief answer. 56.79. In the year 1976, what is the difference between the Exports(as % of merchandise exports) of Paraguay and Exports(as % of merchandise exports) of Sudan?
Your response must be concise. 12.98. In the year 2000, what is the difference between the Exports(as % of merchandise exports) of Iraq and Exports(as % of merchandise exports) of Pakistan?
Offer a very short reply. -84.28. In the year 2000, what is the difference between the Exports(as % of merchandise exports) of Iraq and Exports(as % of merchandise exports) of Paraguay?
Make the answer very short. -18.46. In the year 2000, what is the difference between the Exports(as % of merchandise exports) of Iraq and Exports(as % of merchandise exports) of Sudan?
Your answer should be compact. -7.46. In the year 2000, what is the difference between the Exports(as % of merchandise exports) of Pakistan and Exports(as % of merchandise exports) of Paraguay?
Make the answer very short. 65.82. In the year 2000, what is the difference between the Exports(as % of merchandise exports) in Pakistan and Exports(as % of merchandise exports) in Sudan?
Offer a very short reply. 76.82. In the year 2000, what is the difference between the Exports(as % of merchandise exports) of Paraguay and Exports(as % of merchandise exports) of Sudan?
Ensure brevity in your answer.  11. What is the ratio of the Exports(as % of merchandise exports) of Iraq in 1963 to that in 1972?
Your response must be concise. 0.03. What is the ratio of the Exports(as % of merchandise exports) in Pakistan in 1963 to that in 1972?
Offer a very short reply. 0.47. What is the ratio of the Exports(as % of merchandise exports) in Paraguay in 1963 to that in 1972?
Your response must be concise. 0.98. What is the ratio of the Exports(as % of merchandise exports) in Sudan in 1963 to that in 1972?
Your answer should be compact. 1.49. What is the ratio of the Exports(as % of merchandise exports) of Iraq in 1963 to that in 1973?
Your answer should be compact. 0.03. What is the ratio of the Exports(as % of merchandise exports) of Pakistan in 1963 to that in 1973?
Make the answer very short. 0.42. What is the ratio of the Exports(as % of merchandise exports) of Paraguay in 1963 to that in 1973?
Provide a short and direct response. 0.83. What is the ratio of the Exports(as % of merchandise exports) of Iraq in 1963 to that in 1974?
Provide a short and direct response. 0.03. What is the ratio of the Exports(as % of merchandise exports) of Pakistan in 1963 to that in 1974?
Make the answer very short. 0.5. What is the ratio of the Exports(as % of merchandise exports) in Paraguay in 1963 to that in 1974?
Your answer should be compact. 1.03. What is the ratio of the Exports(as % of merchandise exports) of Sudan in 1963 to that in 1974?
Make the answer very short. 1.09. What is the ratio of the Exports(as % of merchandise exports) of Iraq in 1963 to that in 1975?
Make the answer very short. 0.04. What is the ratio of the Exports(as % of merchandise exports) in Pakistan in 1963 to that in 1975?
Provide a short and direct response. 0.48. What is the ratio of the Exports(as % of merchandise exports) in Paraguay in 1963 to that in 1975?
Offer a very short reply. 1.01. What is the ratio of the Exports(as % of merchandise exports) of Sudan in 1963 to that in 1975?
Keep it short and to the point. 0.64. What is the ratio of the Exports(as % of merchandise exports) of Iraq in 1963 to that in 1976?
Offer a terse response. 0.03. What is the ratio of the Exports(as % of merchandise exports) in Pakistan in 1963 to that in 1976?
Your answer should be compact. 0.45. What is the ratio of the Exports(as % of merchandise exports) in Paraguay in 1963 to that in 1976?
Keep it short and to the point. 0.8. What is the ratio of the Exports(as % of merchandise exports) in Sudan in 1963 to that in 1976?
Make the answer very short. 0.38. What is the ratio of the Exports(as % of merchandise exports) in Iraq in 1963 to that in 2000?
Make the answer very short. 1.54. What is the ratio of the Exports(as % of merchandise exports) of Pakistan in 1963 to that in 2000?
Make the answer very short. 0.31. What is the ratio of the Exports(as % of merchandise exports) in Paraguay in 1963 to that in 2000?
Your response must be concise. 0.56. What is the ratio of the Exports(as % of merchandise exports) in Sudan in 1963 to that in 2000?
Your response must be concise. 0.01. What is the ratio of the Exports(as % of merchandise exports) of Iraq in 1972 to that in 1973?
Give a very brief answer. 1.07. What is the ratio of the Exports(as % of merchandise exports) of Pakistan in 1972 to that in 1973?
Keep it short and to the point. 0.89. What is the ratio of the Exports(as % of merchandise exports) of Paraguay in 1972 to that in 1973?
Your answer should be very brief. 0.85. What is the ratio of the Exports(as % of merchandise exports) in Sudan in 1972 to that in 1973?
Offer a terse response. 0.65. What is the ratio of the Exports(as % of merchandise exports) in Iraq in 1972 to that in 1974?
Make the answer very short. 1.08. What is the ratio of the Exports(as % of merchandise exports) of Pakistan in 1972 to that in 1974?
Offer a terse response. 1.06. What is the ratio of the Exports(as % of merchandise exports) of Paraguay in 1972 to that in 1974?
Offer a terse response. 1.05. What is the ratio of the Exports(as % of merchandise exports) in Sudan in 1972 to that in 1974?
Your response must be concise. 0.73. What is the ratio of the Exports(as % of merchandise exports) in Iraq in 1972 to that in 1975?
Provide a succinct answer. 1.48. What is the ratio of the Exports(as % of merchandise exports) of Pakistan in 1972 to that in 1975?
Your answer should be very brief. 1.02. What is the ratio of the Exports(as % of merchandise exports) of Paraguay in 1972 to that in 1975?
Your response must be concise. 1.03. What is the ratio of the Exports(as % of merchandise exports) in Sudan in 1972 to that in 1975?
Offer a very short reply. 0.43. What is the ratio of the Exports(as % of merchandise exports) in Iraq in 1972 to that in 1976?
Keep it short and to the point. 0.94. What is the ratio of the Exports(as % of merchandise exports) in Pakistan in 1972 to that in 1976?
Ensure brevity in your answer.  0.97. What is the ratio of the Exports(as % of merchandise exports) in Paraguay in 1972 to that in 1976?
Your answer should be compact. 0.81. What is the ratio of the Exports(as % of merchandise exports) in Sudan in 1972 to that in 1976?
Provide a short and direct response. 0.25. What is the ratio of the Exports(as % of merchandise exports) in Iraq in 1972 to that in 2000?
Your answer should be compact. 54.37. What is the ratio of the Exports(as % of merchandise exports) of Pakistan in 1972 to that in 2000?
Offer a terse response. 0.65. What is the ratio of the Exports(as % of merchandise exports) of Paraguay in 1972 to that in 2000?
Give a very brief answer. 0.57. What is the ratio of the Exports(as % of merchandise exports) of Sudan in 1972 to that in 2000?
Give a very brief answer. 0.01. What is the ratio of the Exports(as % of merchandise exports) of Iraq in 1973 to that in 1974?
Provide a succinct answer. 1. What is the ratio of the Exports(as % of merchandise exports) of Pakistan in 1973 to that in 1974?
Ensure brevity in your answer.  1.19. What is the ratio of the Exports(as % of merchandise exports) in Paraguay in 1973 to that in 1974?
Ensure brevity in your answer.  1.24. What is the ratio of the Exports(as % of merchandise exports) of Sudan in 1973 to that in 1974?
Your response must be concise. 1.12. What is the ratio of the Exports(as % of merchandise exports) of Iraq in 1973 to that in 1975?
Ensure brevity in your answer.  1.38. What is the ratio of the Exports(as % of merchandise exports) in Pakistan in 1973 to that in 1975?
Give a very brief answer. 1.15. What is the ratio of the Exports(as % of merchandise exports) in Paraguay in 1973 to that in 1975?
Offer a terse response. 1.21. What is the ratio of the Exports(as % of merchandise exports) of Sudan in 1973 to that in 1975?
Offer a very short reply. 0.66. What is the ratio of the Exports(as % of merchandise exports) in Iraq in 1973 to that in 1976?
Your answer should be very brief. 0.87. What is the ratio of the Exports(as % of merchandise exports) of Pakistan in 1973 to that in 1976?
Provide a short and direct response. 1.09. What is the ratio of the Exports(as % of merchandise exports) in Paraguay in 1973 to that in 1976?
Provide a short and direct response. 0.96. What is the ratio of the Exports(as % of merchandise exports) of Sudan in 1973 to that in 1976?
Your response must be concise. 0.39. What is the ratio of the Exports(as % of merchandise exports) in Iraq in 1973 to that in 2000?
Your response must be concise. 50.65. What is the ratio of the Exports(as % of merchandise exports) in Pakistan in 1973 to that in 2000?
Ensure brevity in your answer.  0.74. What is the ratio of the Exports(as % of merchandise exports) of Paraguay in 1973 to that in 2000?
Make the answer very short. 0.67. What is the ratio of the Exports(as % of merchandise exports) in Sudan in 1973 to that in 2000?
Make the answer very short. 0.01. What is the ratio of the Exports(as % of merchandise exports) in Iraq in 1974 to that in 1975?
Make the answer very short. 1.37. What is the ratio of the Exports(as % of merchandise exports) in Pakistan in 1974 to that in 1975?
Your answer should be very brief. 0.96. What is the ratio of the Exports(as % of merchandise exports) in Paraguay in 1974 to that in 1975?
Your response must be concise. 0.98. What is the ratio of the Exports(as % of merchandise exports) in Sudan in 1974 to that in 1975?
Your response must be concise. 0.59. What is the ratio of the Exports(as % of merchandise exports) in Iraq in 1974 to that in 1976?
Ensure brevity in your answer.  0.87. What is the ratio of the Exports(as % of merchandise exports) of Pakistan in 1974 to that in 1976?
Make the answer very short. 0.92. What is the ratio of the Exports(as % of merchandise exports) in Paraguay in 1974 to that in 1976?
Offer a very short reply. 0.77. What is the ratio of the Exports(as % of merchandise exports) in Sudan in 1974 to that in 1976?
Provide a succinct answer. 0.35. What is the ratio of the Exports(as % of merchandise exports) of Iraq in 1974 to that in 2000?
Make the answer very short. 50.47. What is the ratio of the Exports(as % of merchandise exports) in Pakistan in 1974 to that in 2000?
Provide a short and direct response. 0.62. What is the ratio of the Exports(as % of merchandise exports) of Paraguay in 1974 to that in 2000?
Offer a terse response. 0.54. What is the ratio of the Exports(as % of merchandise exports) in Sudan in 1974 to that in 2000?
Keep it short and to the point. 0.01. What is the ratio of the Exports(as % of merchandise exports) in Iraq in 1975 to that in 1976?
Your response must be concise. 0.63. What is the ratio of the Exports(as % of merchandise exports) of Pakistan in 1975 to that in 1976?
Your response must be concise. 0.95. What is the ratio of the Exports(as % of merchandise exports) of Paraguay in 1975 to that in 1976?
Offer a very short reply. 0.79. What is the ratio of the Exports(as % of merchandise exports) in Sudan in 1975 to that in 1976?
Ensure brevity in your answer.  0.59. What is the ratio of the Exports(as % of merchandise exports) in Iraq in 1975 to that in 2000?
Keep it short and to the point. 36.82. What is the ratio of the Exports(as % of merchandise exports) in Pakistan in 1975 to that in 2000?
Provide a succinct answer. 0.64. What is the ratio of the Exports(as % of merchandise exports) in Paraguay in 1975 to that in 2000?
Ensure brevity in your answer.  0.55. What is the ratio of the Exports(as % of merchandise exports) in Sudan in 1975 to that in 2000?
Make the answer very short. 0.02. What is the ratio of the Exports(as % of merchandise exports) in Iraq in 1976 to that in 2000?
Provide a short and direct response. 58.09. What is the ratio of the Exports(as % of merchandise exports) of Pakistan in 1976 to that in 2000?
Keep it short and to the point. 0.67. What is the ratio of the Exports(as % of merchandise exports) of Paraguay in 1976 to that in 2000?
Offer a terse response. 0.7. What is the ratio of the Exports(as % of merchandise exports) in Sudan in 1976 to that in 2000?
Your answer should be compact. 0.03. What is the difference between the highest and the second highest Exports(as % of merchandise exports) in Iraq?
Offer a very short reply. 1.55. What is the difference between the highest and the second highest Exports(as % of merchandise exports) in Pakistan?
Provide a succinct answer. 22.32. What is the difference between the highest and the second highest Exports(as % of merchandise exports) in Paraguay?
Provide a short and direct response. 5.67. What is the difference between the highest and the second highest Exports(as % of merchandise exports) in Sudan?
Your answer should be compact. 7.65. What is the difference between the highest and the lowest Exports(as % of merchandise exports) of Iraq?
Provide a succinct answer. 23.79. What is the difference between the highest and the lowest Exports(as % of merchandise exports) of Pakistan?
Keep it short and to the point. 58.76. What is the difference between the highest and the lowest Exports(as % of merchandise exports) in Paraguay?
Ensure brevity in your answer.  8.66. What is the difference between the highest and the lowest Exports(as % of merchandise exports) in Sudan?
Offer a very short reply. 7.82. 